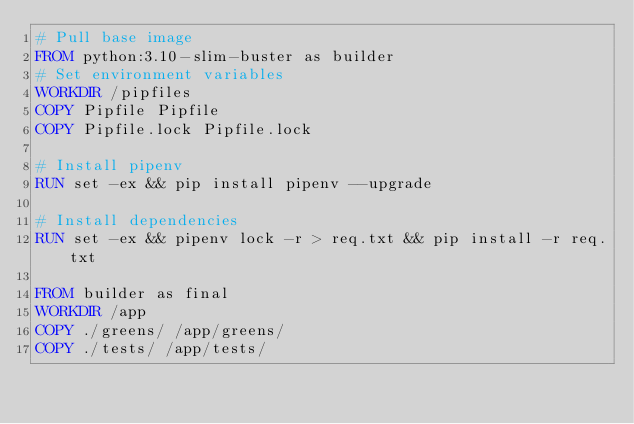<code> <loc_0><loc_0><loc_500><loc_500><_Dockerfile_># Pull base image
FROM python:3.10-slim-buster as builder
# Set environment variables
WORKDIR /pipfiles
COPY Pipfile Pipfile
COPY Pipfile.lock Pipfile.lock

# Install pipenv
RUN set -ex && pip install pipenv --upgrade

# Install dependencies
RUN set -ex && pipenv lock -r > req.txt && pip install -r req.txt

FROM builder as final
WORKDIR /app
COPY ./greens/ /app/greens/
COPY ./tests/ /app/tests/


</code> 